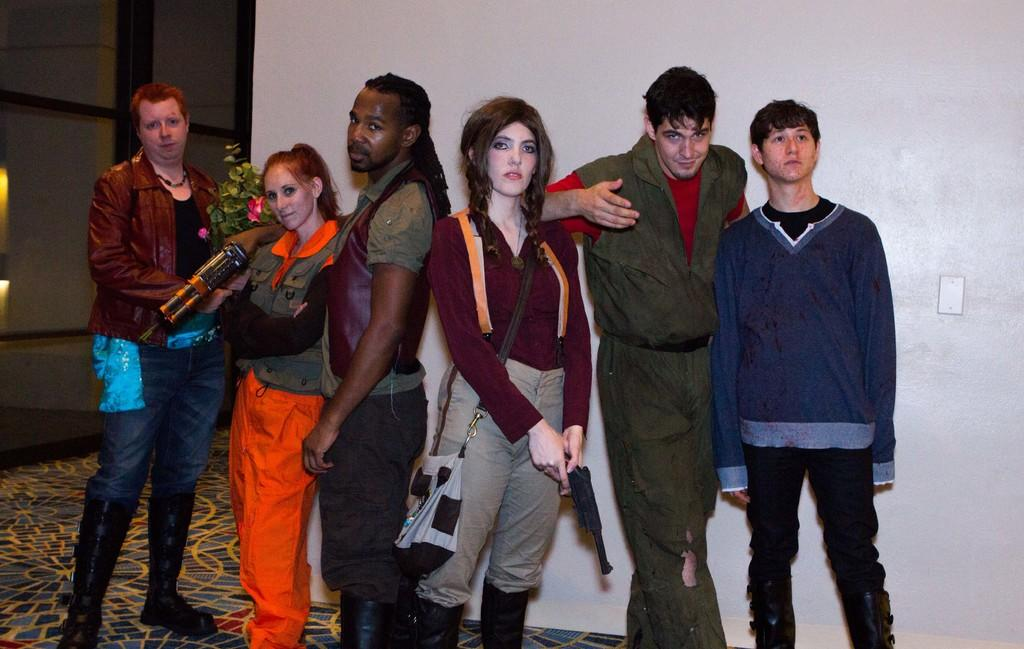How many people are in the image? There is a group of people in the image. What are two people in the group doing? Two people are holding objects. What type of plant can be seen in the image? There is a house plant visible in the image. What architectural feature is present in the image? There is a wall in the image. What type of window is visible in the image? There is a glass window in the image. What type of rhythm can be heard from the wheel in the image? There is no wheel present in the image, and therefore no rhythm can be heard. 